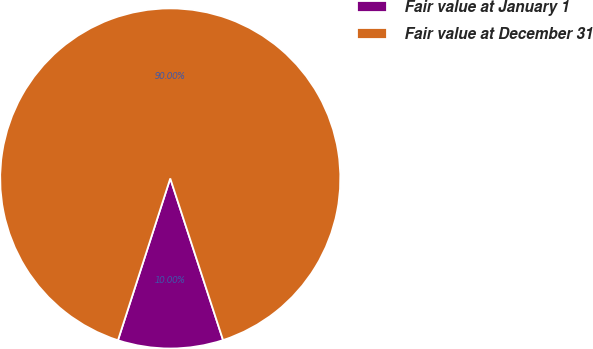<chart> <loc_0><loc_0><loc_500><loc_500><pie_chart><fcel>Fair value at January 1<fcel>Fair value at December 31<nl><fcel>10.0%<fcel>90.0%<nl></chart> 